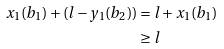<formula> <loc_0><loc_0><loc_500><loc_500>x _ { 1 } ( b _ { 1 } ) + ( l - y _ { 1 } ( b _ { 2 } ) ) & = l + x _ { 1 } ( b _ { 1 } ) \\ & \geq l</formula> 